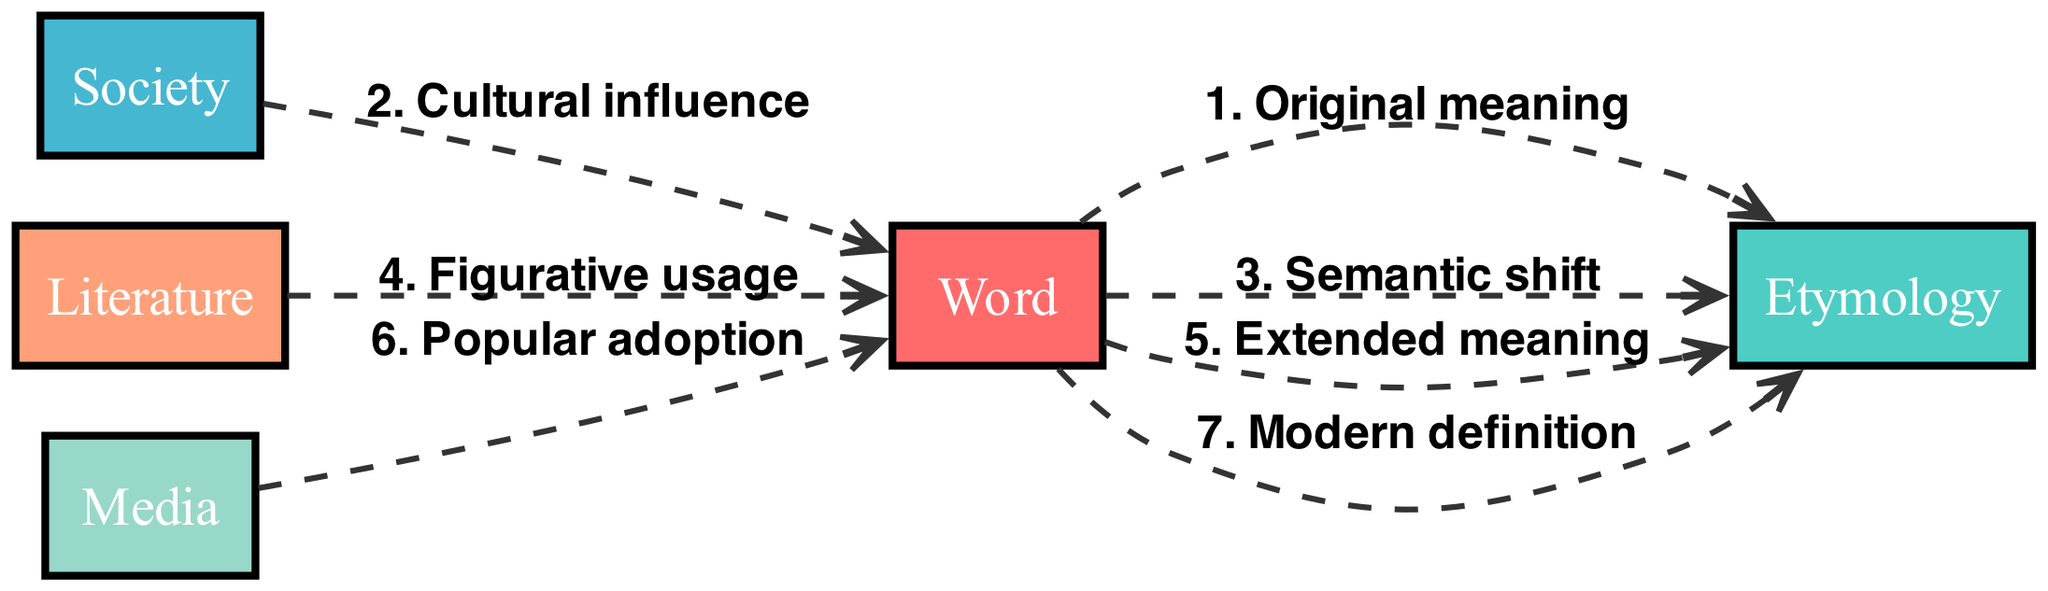What is the original meaning of the word? The diagram indicates that the "Original meaning" is an interaction directly from the "Word" to "Etymology", which denotes the definition before any changes occurred.
Answer: Original meaning How many objects are present in the diagram? By counting the items listed under "objects", we find there are five total entities: Word, Etymology, Society, Literature, and Media.
Answer: 5 What cultural influence affects the word? The diagram shows that "Society" influences the "Word" through the message labeled "Cultural influence", indicating that societal shifts can affect the meaning of a word.
Answer: Cultural influence What is the relationship between literature and the word? The diagram shows a direct connection from "Literature" to "Word" with the message "Figurative usage", illustrating how literary contexts can alter or embellish the meaning of a word.
Answer: Figurative usage What signifies the modern definition of the word? The flow of the diagram indicates that after several interactions, the final check from "Word" back to "Etymology" results in a "Modern definition", showcasing how contemporary usage dictates meaning.
Answer: Modern definition What message does media convey to the word? In the diagram, "Media" influences the "Word" with the message "Popular adoption", indicating how media can popularize certain meanings or usages of words in society.
Answer: Popular adoption How many edges are in the diagram? Counting the connections (edges) between the objects, there are six distinct edges representing various meanings and influences.
Answer: 6 What comes after the semantic shift? Following the sequence from "Word" to "Etymology" leads to the "Extended meaning", which suggests that after the initial semantic shift, the meaning of the word continues to evolve.
Answer: Extended meaning 